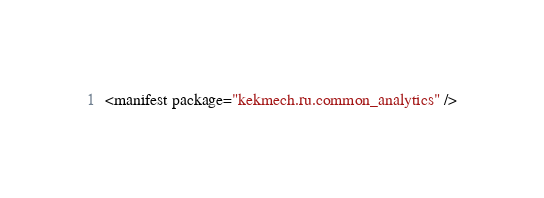Convert code to text. <code><loc_0><loc_0><loc_500><loc_500><_XML_><manifest package="kekmech.ru.common_analytics" /></code> 